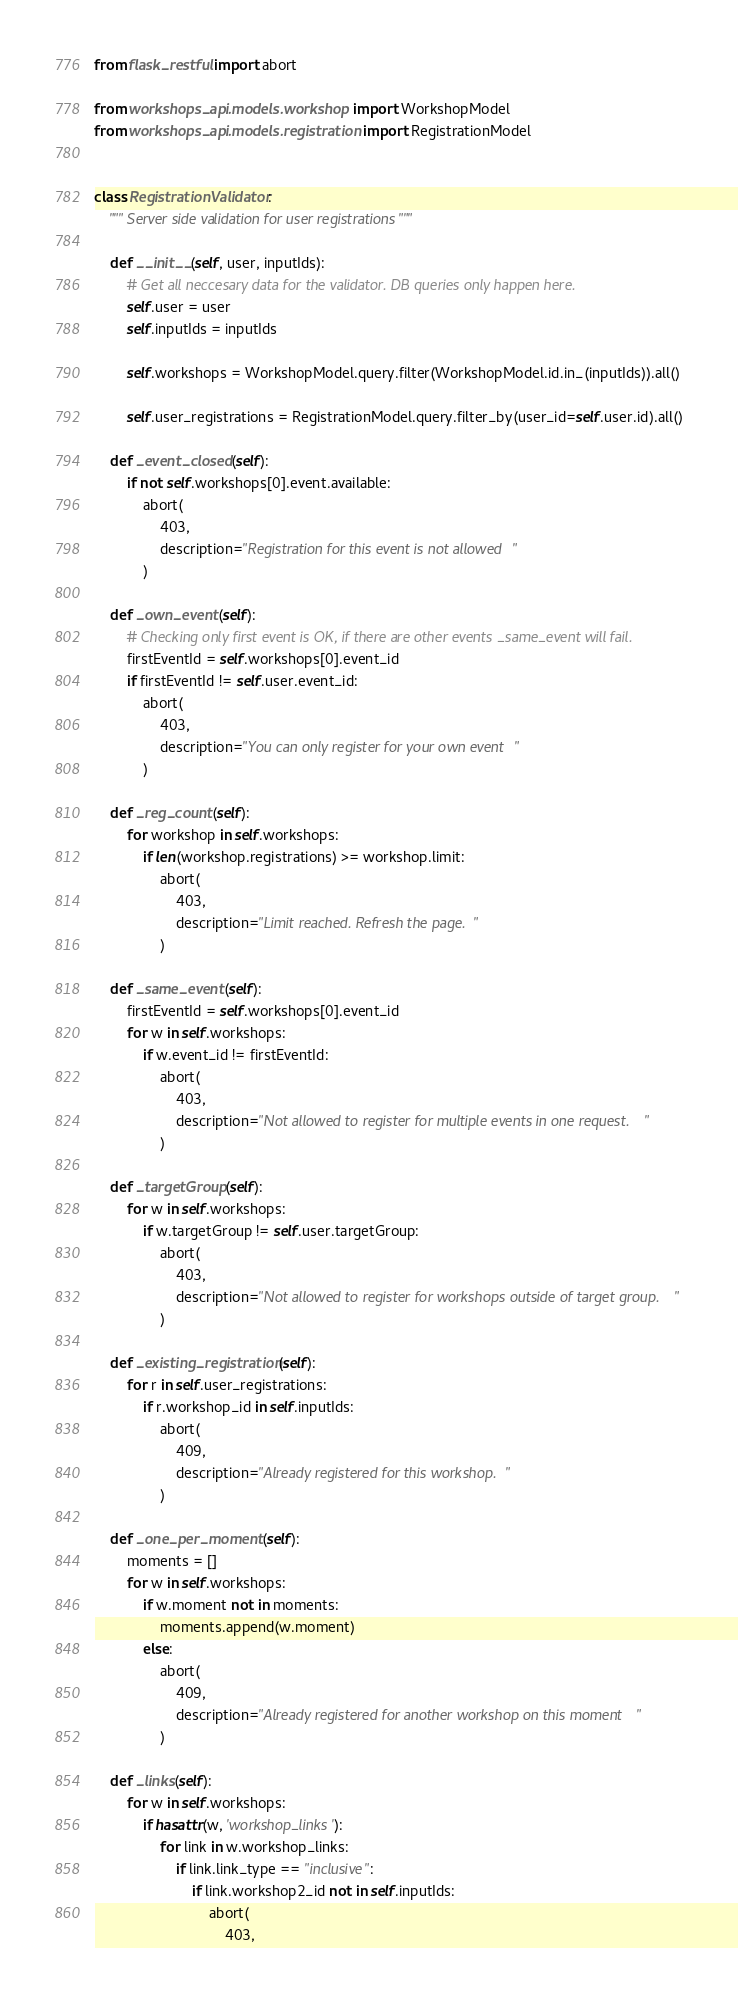Convert code to text. <code><loc_0><loc_0><loc_500><loc_500><_Python_>from flask_restful import abort

from workshops_api.models.workshop import WorkshopModel
from workshops_api.models.registration import RegistrationModel


class RegistrationValidator:
    """ Server side validation for user registrations """

    def __init__(self, user, inputIds):
        # Get all neccesary data for the validator. DB queries only happen here.
        self.user = user
        self.inputIds = inputIds

        self.workshops = WorkshopModel.query.filter(WorkshopModel.id.in_(inputIds)).all()

        self.user_registrations = RegistrationModel.query.filter_by(user_id=self.user.id).all()

    def _event_closed(self):
        if not self.workshops[0].event.available:
            abort(
                403,
                description="Registration for this event is not allowed"
            )

    def _own_event(self):
        # Checking only first event is OK, if there are other events _same_event will fail.
        firstEventId = self.workshops[0].event_id
        if firstEventId != self.user.event_id:
            abort(
                403,
                description="You can only register for your own event"
            )

    def _reg_count(self):
        for workshop in self.workshops:
            if len(workshop.registrations) >= workshop.limit:
                abort(
                    403,
                    description="Limit reached. Refresh the page."
                )

    def _same_event(self):
        firstEventId = self.workshops[0].event_id
        for w in self.workshops:
            if w.event_id != firstEventId:
                abort(
                    403,
                    description="Not allowed to register for multiple events in one request."
                )

    def _targetGroup(self):
        for w in self.workshops:
            if w.targetGroup != self.user.targetGroup:
                abort(
                    403,
                    description="Not allowed to register for workshops outside of target group."
                )

    def _existing_registration(self):
        for r in self.user_registrations:
            if r.workshop_id in self.inputIds:
                abort(
                    409,
                    description="Already registered for this workshop."
                )

    def _one_per_moment(self):
        moments = []
        for w in self.workshops:
            if w.moment not in moments:
                moments.append(w.moment)
            else:
                abort(
                    409,
                    description="Already registered for another workshop on this moment"
                )

    def _links(self):
        for w in self.workshops:
            if hasattr(w, 'workshop_links'):
                for link in w.workshop_links:
                    if link.link_type == "inclusive":
                        if link.workshop2_id not in self.inputIds:
                            abort(
                                403,</code> 